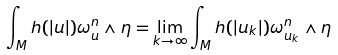Convert formula to latex. <formula><loc_0><loc_0><loc_500><loc_500>\int _ { M } h ( | u | ) \omega _ { u } ^ { n } \wedge \eta = \lim _ { k \rightarrow \infty } \int _ { M } h ( | u _ { k } | ) \omega _ { u _ { k } } ^ { n } \wedge \eta</formula> 